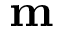Convert formula to latex. <formula><loc_0><loc_0><loc_500><loc_500>m</formula> 